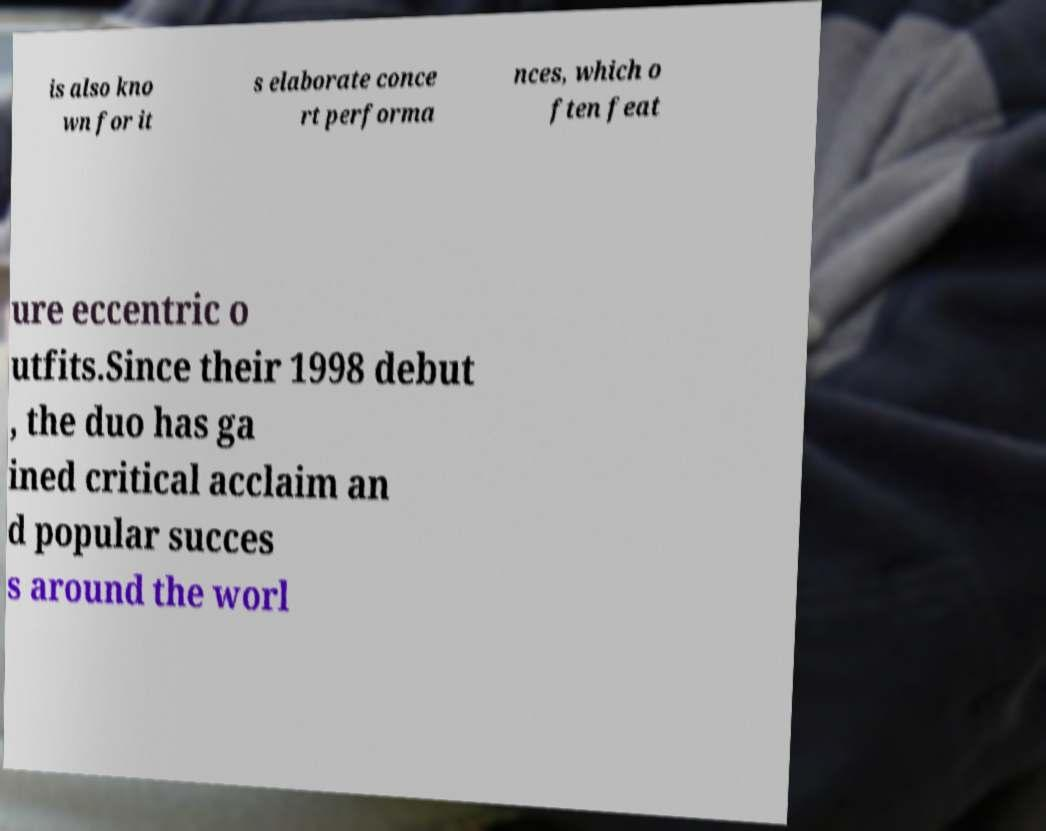What messages or text are displayed in this image? I need them in a readable, typed format. is also kno wn for it s elaborate conce rt performa nces, which o ften feat ure eccentric o utfits.Since their 1998 debut , the duo has ga ined critical acclaim an d popular succes s around the worl 